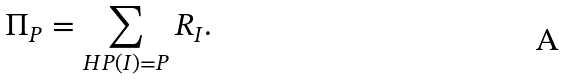Convert formula to latex. <formula><loc_0><loc_0><loc_500><loc_500>\Pi _ { P } = \sum _ { H P ( I ) = P } R _ { I } .</formula> 